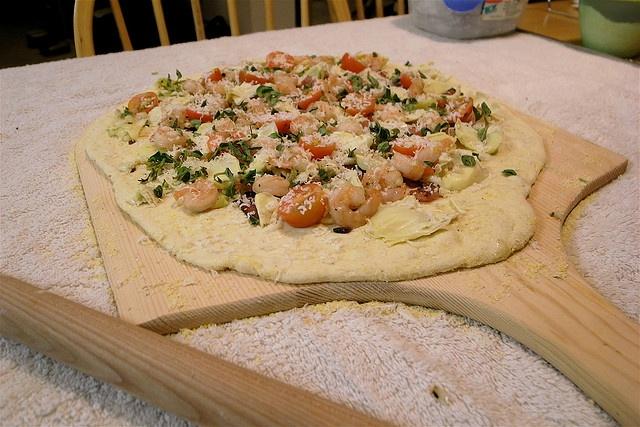Describe the objects in this image and their specific colors. I can see dining table in tan, darkgray, and gray tones, pizza in black, tan, and olive tones, chair in black, maroon, and olive tones, and chair in black, maroon, and olive tones in this image. 